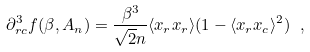Convert formula to latex. <formula><loc_0><loc_0><loc_500><loc_500>\partial ^ { 3 } _ { r c } f ( \beta , A _ { n } ) = \frac { \beta ^ { 3 } } { \sqrt { 2 } n } \langle x _ { r } x _ { r } \rangle ( 1 - \langle x _ { r } x _ { c } \rangle ^ { 2 } ) \ ,</formula> 